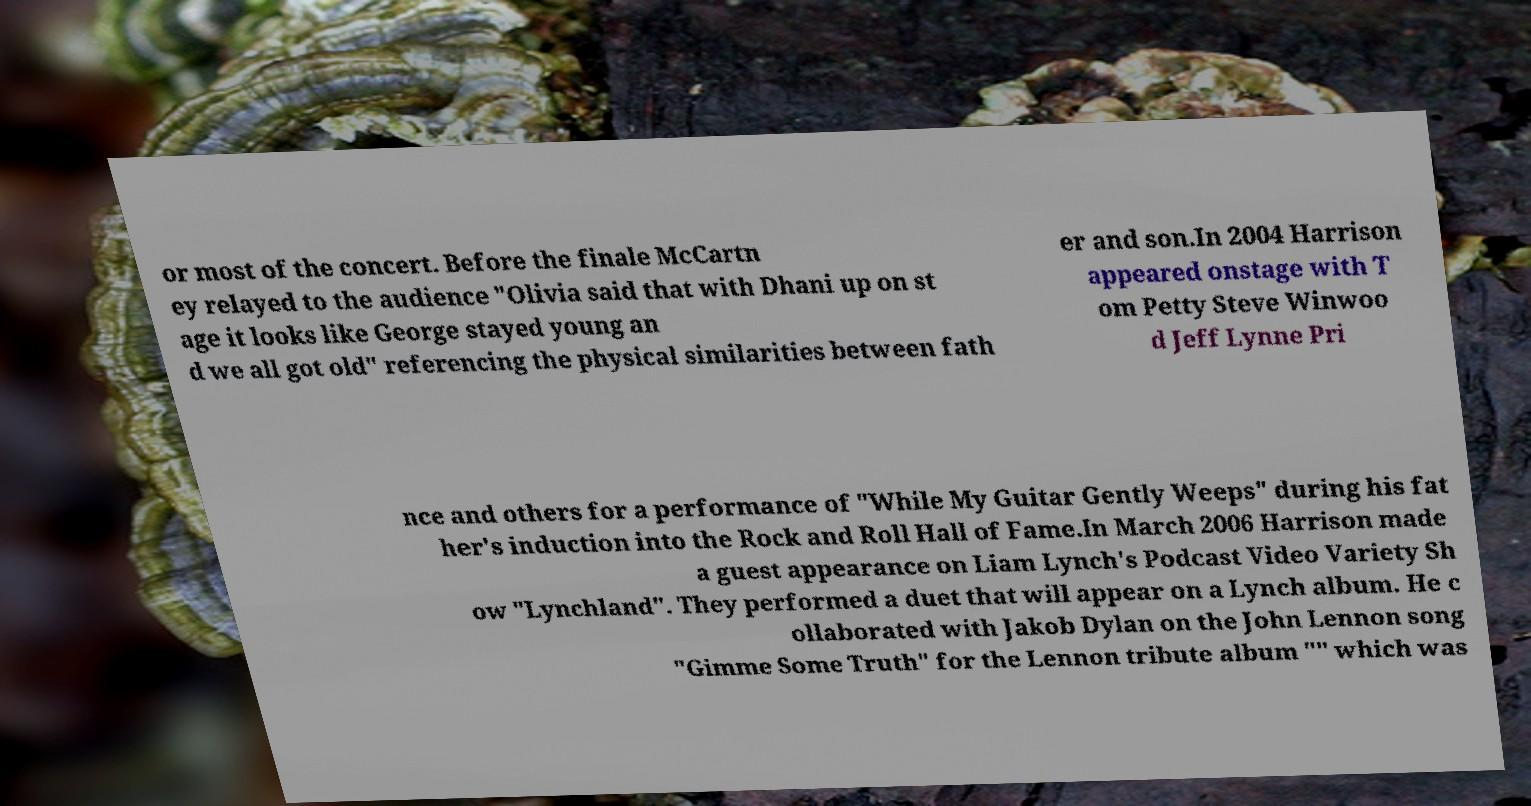Please identify and transcribe the text found in this image. or most of the concert. Before the finale McCartn ey relayed to the audience "Olivia said that with Dhani up on st age it looks like George stayed young an d we all got old" referencing the physical similarities between fath er and son.In 2004 Harrison appeared onstage with T om Petty Steve Winwoo d Jeff Lynne Pri nce and others for a performance of "While My Guitar Gently Weeps" during his fat her's induction into the Rock and Roll Hall of Fame.In March 2006 Harrison made a guest appearance on Liam Lynch's Podcast Video Variety Sh ow "Lynchland". They performed a duet that will appear on a Lynch album. He c ollaborated with Jakob Dylan on the John Lennon song "Gimme Some Truth" for the Lennon tribute album "" which was 